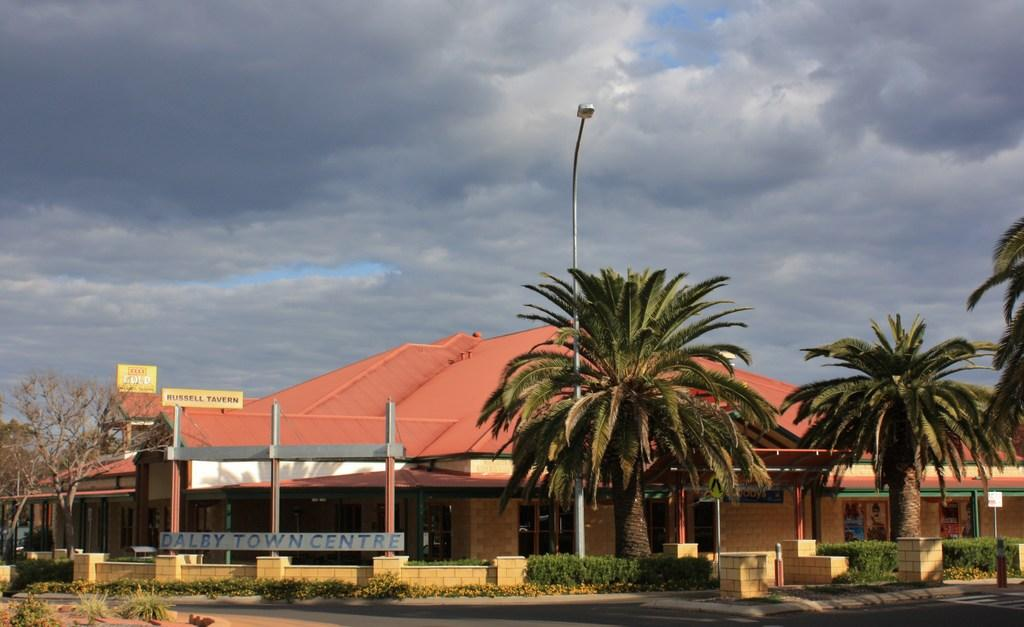What is the main feature of the image? There is a road in the image. What structures can be seen along the road? Name boards, a wall, and a house are present in the image. What type of vegetation is visible in the image? Shrubs and trees are present in the image. What is the condition of the sky in the background? The sky in the background is cloudy. What other object can be seen in the image? A light pole is in the image. Can you see any roses growing along the road in the image? There are no roses visible in the image; only shrubs and trees are present. 